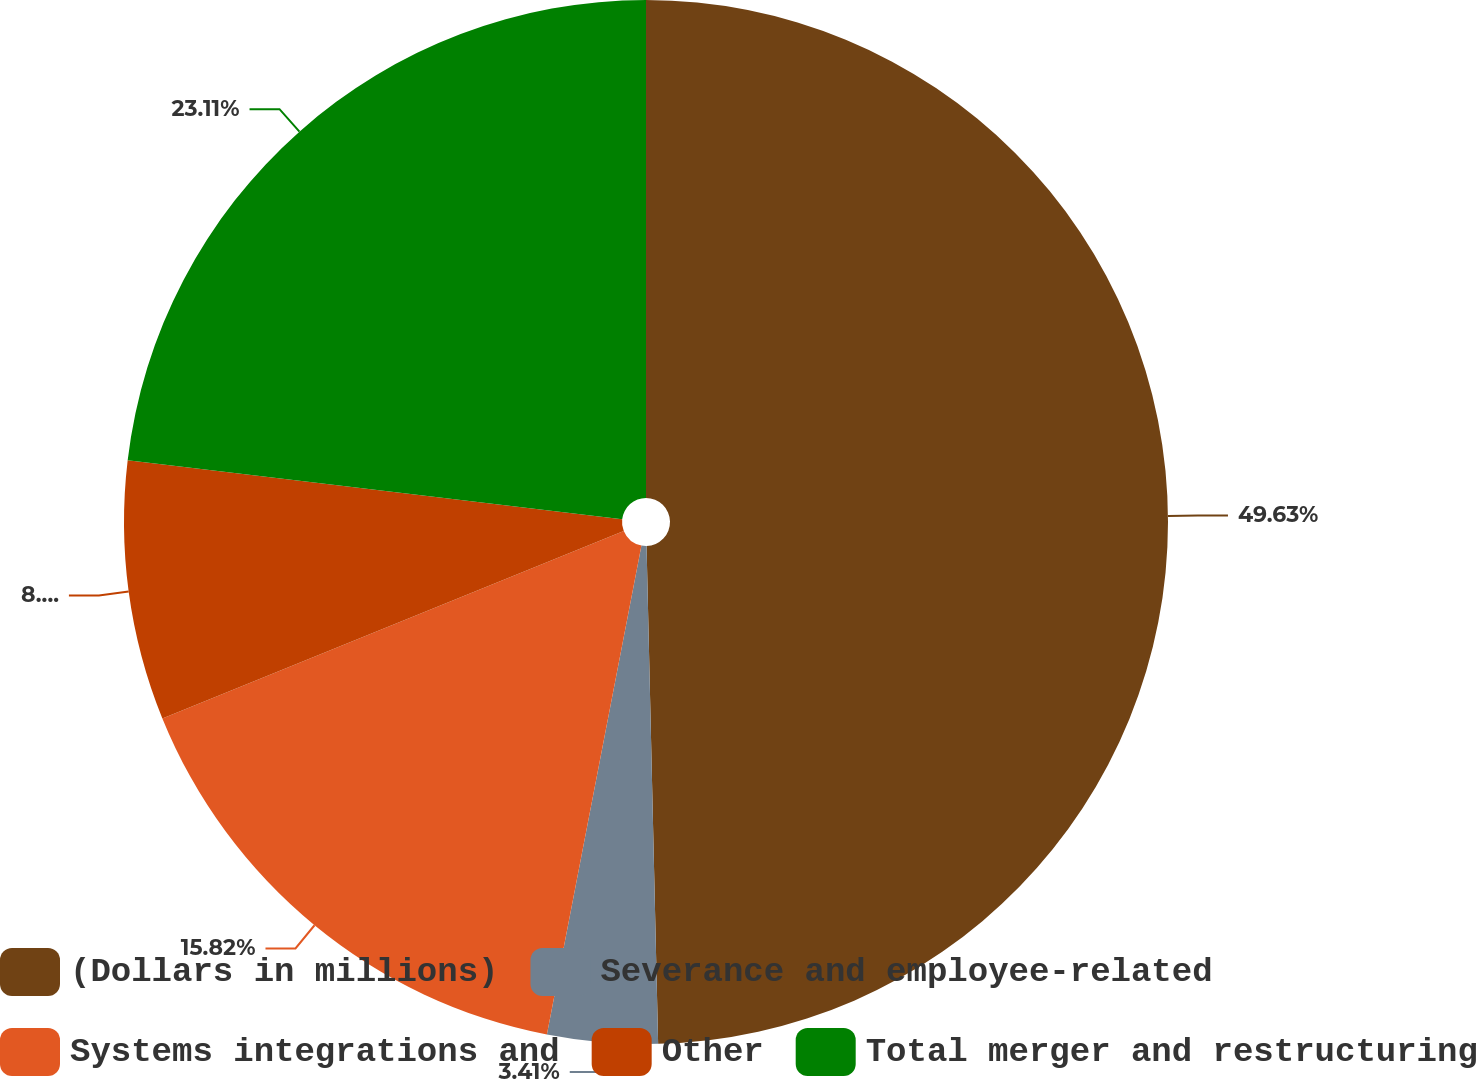Convert chart. <chart><loc_0><loc_0><loc_500><loc_500><pie_chart><fcel>(Dollars in millions)<fcel>Severance and employee-related<fcel>Systems integrations and<fcel>Other<fcel>Total merger and restructuring<nl><fcel>49.63%<fcel>3.41%<fcel>15.82%<fcel>8.03%<fcel>23.11%<nl></chart> 